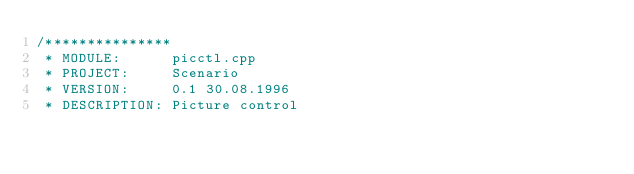<code> <loc_0><loc_0><loc_500><loc_500><_C++_>/***************
 * MODULE:			picctl.cpp
 * PROJECT:			Scenario
 * VERSION:			0.1 30.08.1996
 * DESCRIPTION:	Picture control</code> 